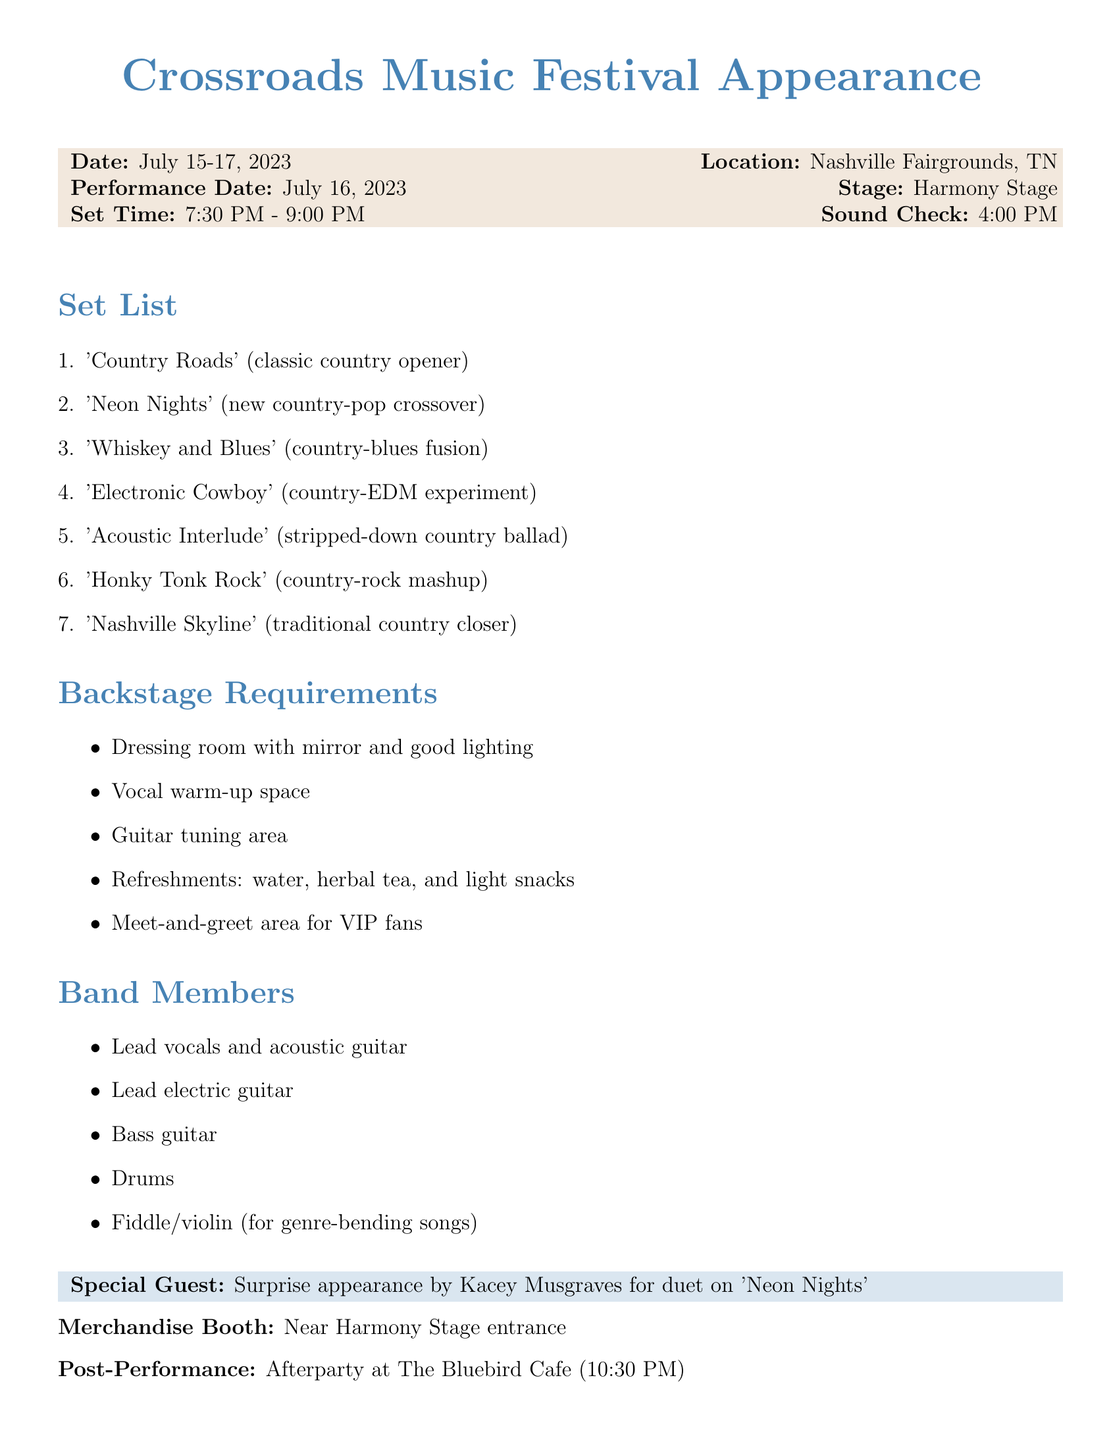What is the name of the festival? The document mentions 'Crossroads Music Festival' as the name of the festival.
Answer: Crossroads Music Festival When is the performance date? The performance date is explicitly stated in the document as July 16, 2023.
Answer: July 16, 2023 What time is the set scheduled? The set time is provided in the document as 7:30 PM - 9:00 PM.
Answer: 7:30 PM - 9:00 PM Who is the special guest for the performance? The document mentions a surprise appearance by Kacey Musgraves for the duet on 'Neon Nights.'
Answer: Kacey Musgraves What time is the sound check? The sound check time is mentioned as 4:00 PM in the document.
Answer: 4:00 PM How many songs are in the set list? The document lists a total of seven songs in the set list.
Answer: Seven What is listed under backstage requirements? Backstage requirements include items like dressing room with mirror and good lighting as per the document.
Answer: Dressing room with mirror and good lighting Where is the merchandise booth located? The document states the merchandise booth is near the Harmony Stage entrance.
Answer: Near Harmony Stage entrance What is the scheduled afterparty location? The document specifies the afterparty will be at The Bluebird Cafe.
Answer: The Bluebird Cafe 